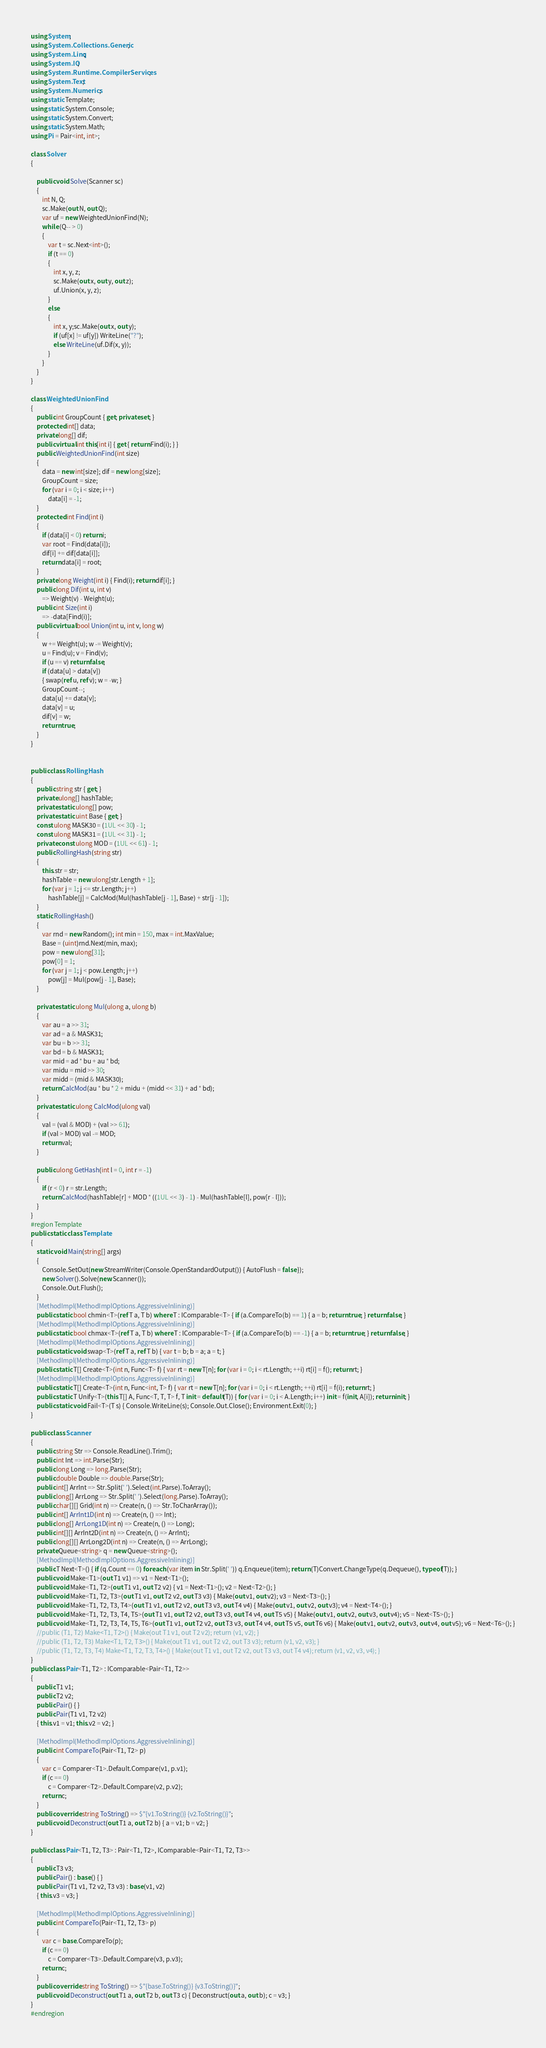Convert code to text. <code><loc_0><loc_0><loc_500><loc_500><_C#_>using System;
using System.Collections.Generic;
using System.Linq;
using System.IO;
using System.Runtime.CompilerServices;
using System.Text;
using System.Numerics;
using static Template;
using static System.Console;
using static System.Convert;
using static System.Math;
using Pi = Pair<int, int>;

class Solver
{

    public void Solve(Scanner sc)
    {
        int N, Q;
        sc.Make(out N, out Q);
        var uf = new WeightedUnionFind(N);
        while (Q-- > 0)
        {
            var t = sc.Next<int>();
            if (t == 0)
            {
                int x, y, z;
                sc.Make(out x, out y, out z);
                uf.Union(x, y, z);
            }
            else
            {
                int x, y;sc.Make(out x, out y);
                if (uf[x] != uf[y]) WriteLine("?");
                else WriteLine(uf.Dif(x, y));
            }
        }
    }
}

class WeightedUnionFind
{
    public int GroupCount { get; private set; }
    protected int[] data;
    private long[] dif;
    public virtual int this[int i] { get { return Find(i); } }
    public WeightedUnionFind(int size)
    {
        data = new int[size]; dif = new long[size];
        GroupCount = size;
        for (var i = 0; i < size; i++)
            data[i] = -1;
    }
    protected int Find(int i)
    {
        if (data[i] < 0) return i;
        var root = Find(data[i]);
        dif[i] += dif[data[i]];
        return data[i] = root;
    }
    private long Weight(int i) { Find(i); return dif[i]; }
    public long Dif(int u, int v)
        => Weight(v) - Weight(u);
    public int Size(int i)
        => -data[Find(i)];
    public virtual bool Union(int u, int v, long w)
    {
        w += Weight(u); w -= Weight(v);
        u = Find(u); v = Find(v);
        if (u == v) return false;
        if (data[u] > data[v])
        { swap(ref u, ref v); w = -w; }
        GroupCount--;
        data[u] += data[v];
        data[v] = u;
        dif[v] = w;
        return true;
    }
}


public class RollingHash
{
    public string str { get; }
    private ulong[] hashTable;
    private static ulong[] pow;
    private static uint Base { get; }
    const ulong MASK30 = (1UL << 30) - 1;
    const ulong MASK31 = (1UL << 31) - 1;
    private const ulong MOD = (1UL << 61) - 1;
    public RollingHash(string str)
    {
        this.str = str;
        hashTable = new ulong[str.Length + 1];
        for (var j = 1; j <= str.Length; j++)
            hashTable[j] = CalcMod(Mul(hashTable[j - 1], Base) + str[j - 1]);
    }
    static RollingHash()
    {
        var rnd = new Random(); int min = 150, max = int.MaxValue;
        Base = (uint)rnd.Next(min, max);
        pow = new ulong[31];
        pow[0] = 1;
        for (var j = 1; j < pow.Length; j++)
            pow[j] = Mul(pow[j - 1], Base);
    }

    private static ulong Mul(ulong a, ulong b)
    {
        var au = a >> 31;
        var ad = a & MASK31;
        var bu = b >> 31;
        var bd = b & MASK31;
        var mid = ad * bu + au * bd;
        var midu = mid >> 30;
        var midd = (mid & MASK30);
        return CalcMod(au * bu * 2 + midu + (midd << 31) + ad * bd);
    }
    private static ulong CalcMod(ulong val)
    {
        val = (val & MOD) + (val >> 61);
        if (val > MOD) val -= MOD;
        return val;
    }

    public ulong GetHash(int l = 0, int r = -1)
    {
        if (r < 0) r = str.Length;
        return CalcMod(hashTable[r] + MOD * ((1UL << 3) - 1) - Mul(hashTable[l], pow[r - l]));
    }
}
#region Template
public static class Template
{
    static void Main(string[] args)
    {
        Console.SetOut(new StreamWriter(Console.OpenStandardOutput()) { AutoFlush = false });
        new Solver().Solve(new Scanner());
        Console.Out.Flush();
    }
    [MethodImpl(MethodImplOptions.AggressiveInlining)]
    public static bool chmin<T>(ref T a, T b) where T : IComparable<T> { if (a.CompareTo(b) == 1) { a = b; return true; } return false; }
    [MethodImpl(MethodImplOptions.AggressiveInlining)]
    public static bool chmax<T>(ref T a, T b) where T : IComparable<T> { if (a.CompareTo(b) == -1) { a = b; return true; } return false; }
    [MethodImpl(MethodImplOptions.AggressiveInlining)]
    public static void swap<T>(ref T a, ref T b) { var t = b; b = a; a = t; }
    [MethodImpl(MethodImplOptions.AggressiveInlining)]
    public static T[] Create<T>(int n, Func<T> f) { var rt = new T[n]; for (var i = 0; i < rt.Length; ++i) rt[i] = f(); return rt; }
    [MethodImpl(MethodImplOptions.AggressiveInlining)]
    public static T[] Create<T>(int n, Func<int, T> f) { var rt = new T[n]; for (var i = 0; i < rt.Length; ++i) rt[i] = f(i); return rt; }
    public static T Unify<T>(this T[] A, Func<T, T, T> f, T init = default(T)) { for (var i = 0; i < A.Length; i++) init = f(init, A[i]); return init; }
    public static void Fail<T>(T s) { Console.WriteLine(s); Console.Out.Close(); Environment.Exit(0); }
}

public class Scanner
{
    public string Str => Console.ReadLine().Trim();
    public int Int => int.Parse(Str);
    public long Long => long.Parse(Str);
    public double Double => double.Parse(Str);
    public int[] ArrInt => Str.Split(' ').Select(int.Parse).ToArray();
    public long[] ArrLong => Str.Split(' ').Select(long.Parse).ToArray();
    public char[][] Grid(int n) => Create(n, () => Str.ToCharArray());
    public int[] ArrInt1D(int n) => Create(n, () => Int);
    public long[] ArrLong1D(int n) => Create(n, () => Long);
    public int[][] ArrInt2D(int n) => Create(n, () => ArrInt);
    public long[][] ArrLong2D(int n) => Create(n, () => ArrLong);
    private Queue<string> q = new Queue<string>();
    [MethodImpl(MethodImplOptions.AggressiveInlining)]
    public T Next<T>() { if (q.Count == 0) foreach (var item in Str.Split(' ')) q.Enqueue(item); return (T)Convert.ChangeType(q.Dequeue(), typeof(T)); }
    public void Make<T1>(out T1 v1) => v1 = Next<T1>();
    public void Make<T1, T2>(out T1 v1, out T2 v2) { v1 = Next<T1>(); v2 = Next<T2>(); }
    public void Make<T1, T2, T3>(out T1 v1, out T2 v2, out T3 v3) { Make(out v1, out v2); v3 = Next<T3>(); }
    public void Make<T1, T2, T3, T4>(out T1 v1, out T2 v2, out T3 v3, out T4 v4) { Make(out v1, out v2, out v3); v4 = Next<T4>(); }
    public void Make<T1, T2, T3, T4, T5>(out T1 v1, out T2 v2, out T3 v3, out T4 v4, out T5 v5) { Make(out v1, out v2, out v3, out v4); v5 = Next<T5>(); }
    public void Make<T1, T2, T3, T4, T5, T6>(out T1 v1, out T2 v2, out T3 v3, out T4 v4, out T5 v5, out T6 v6) { Make(out v1, out v2, out v3, out v4, out v5); v6 = Next<T6>(); }
    //public (T1, T2) Make<T1, T2>() { Make(out T1 v1, out T2 v2); return (v1, v2); }
    //public (T1, T2, T3) Make<T1, T2, T3>() { Make(out T1 v1, out T2 v2, out T3 v3); return (v1, v2, v3); }
    //public (T1, T2, T3, T4) Make<T1, T2, T3, T4>() { Make(out T1 v1, out T2 v2, out T3 v3, out T4 v4); return (v1, v2, v3, v4); }
}
public class Pair<T1, T2> : IComparable<Pair<T1, T2>>
{
    public T1 v1;
    public T2 v2;
    public Pair() { }
    public Pair(T1 v1, T2 v2)
    { this.v1 = v1; this.v2 = v2; }

    [MethodImpl(MethodImplOptions.AggressiveInlining)]
    public int CompareTo(Pair<T1, T2> p)
    {
        var c = Comparer<T1>.Default.Compare(v1, p.v1);
        if (c == 0)
            c = Comparer<T2>.Default.Compare(v2, p.v2);
        return c;
    }
    public override string ToString() => $"{v1.ToString()} {v2.ToString()}";
    public void Deconstruct(out T1 a, out T2 b) { a = v1; b = v2; }
}

public class Pair<T1, T2, T3> : Pair<T1, T2>, IComparable<Pair<T1, T2, T3>>
{
    public T3 v3;
    public Pair() : base() { }
    public Pair(T1 v1, T2 v2, T3 v3) : base(v1, v2)
    { this.v3 = v3; }

    [MethodImpl(MethodImplOptions.AggressiveInlining)]
    public int CompareTo(Pair<T1, T2, T3> p)
    {
        var c = base.CompareTo(p);
        if (c == 0)
            c = Comparer<T3>.Default.Compare(v3, p.v3);
        return c;
    }
    public override string ToString() => $"{base.ToString()} {v3.ToString()}";
    public void Deconstruct(out T1 a, out T2 b, out T3 c) { Deconstruct(out a, out b); c = v3; }
}
#endregion
</code> 